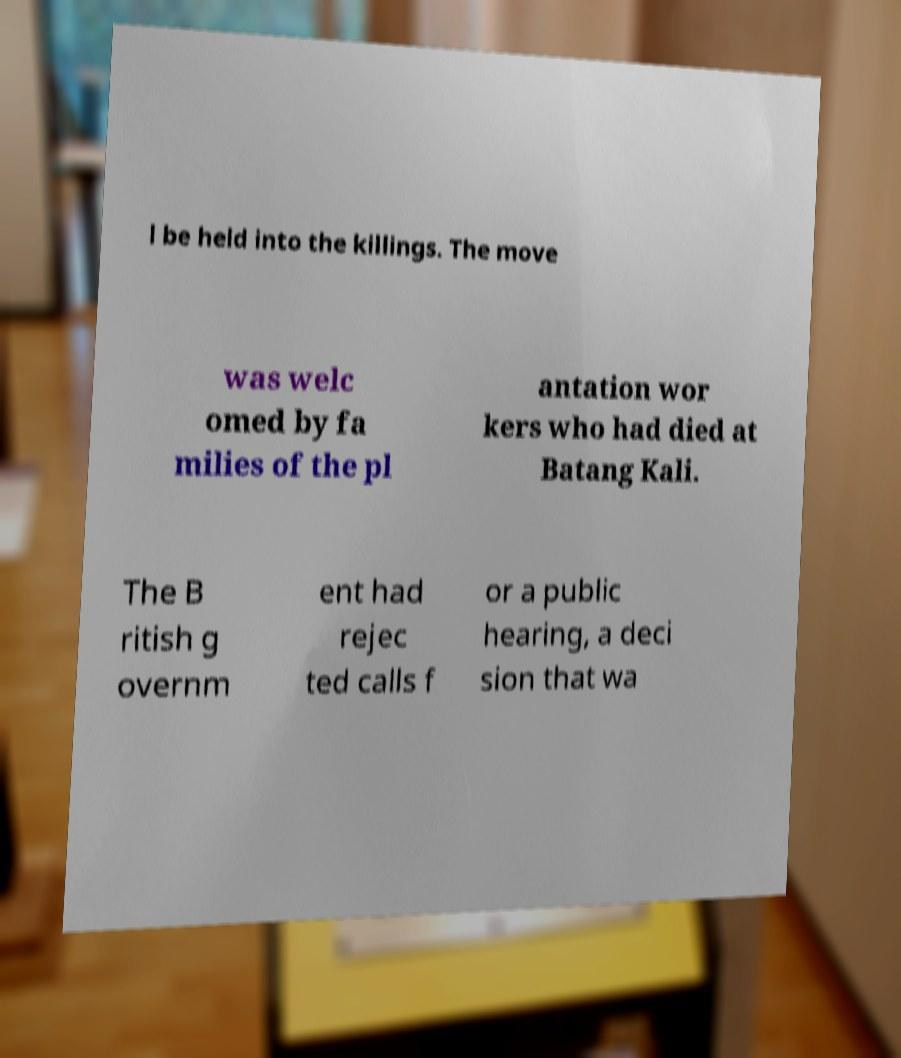There's text embedded in this image that I need extracted. Can you transcribe it verbatim? l be held into the killings. The move was welc omed by fa milies of the pl antation wor kers who had died at Batang Kali. The B ritish g overnm ent had rejec ted calls f or a public hearing, a deci sion that wa 